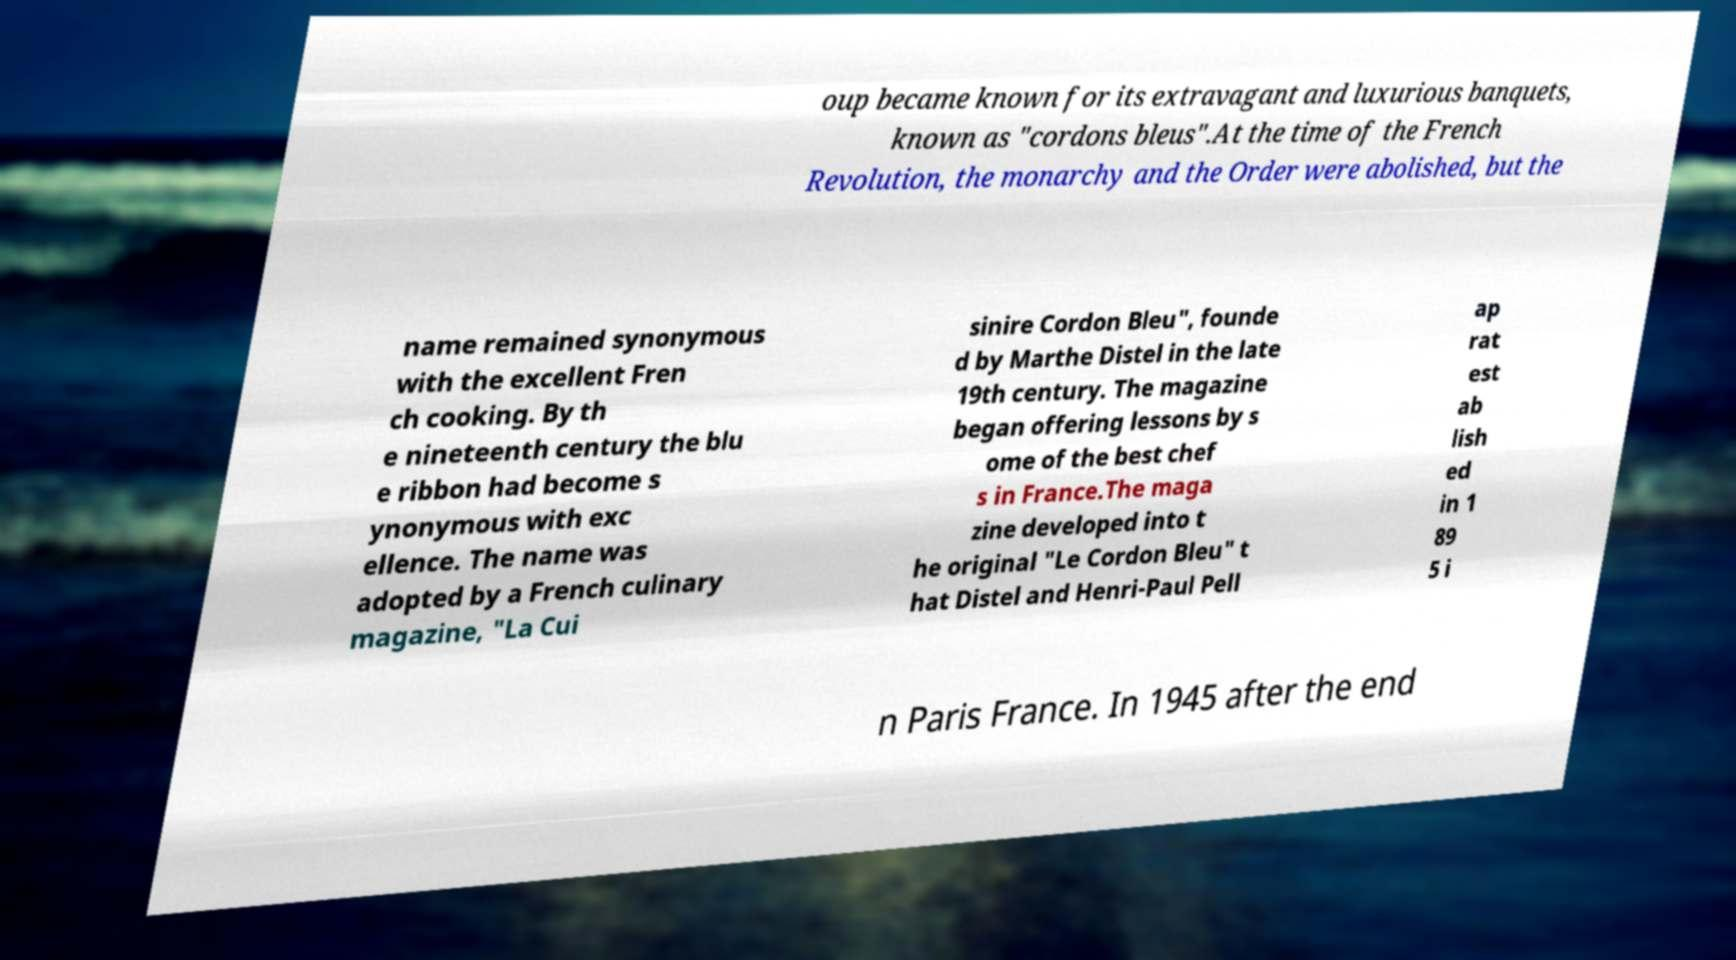Could you assist in decoding the text presented in this image and type it out clearly? oup became known for its extravagant and luxurious banquets, known as "cordons bleus".At the time of the French Revolution, the monarchy and the Order were abolished, but the name remained synonymous with the excellent Fren ch cooking. By th e nineteenth century the blu e ribbon had become s ynonymous with exc ellence. The name was adopted by a French culinary magazine, "La Cui sinire Cordon Bleu", founde d by Marthe Distel in the late 19th century. The magazine began offering lessons by s ome of the best chef s in France.The maga zine developed into t he original "Le Cordon Bleu" t hat Distel and Henri-Paul Pell ap rat est ab lish ed in 1 89 5 i n Paris France. In 1945 after the end 